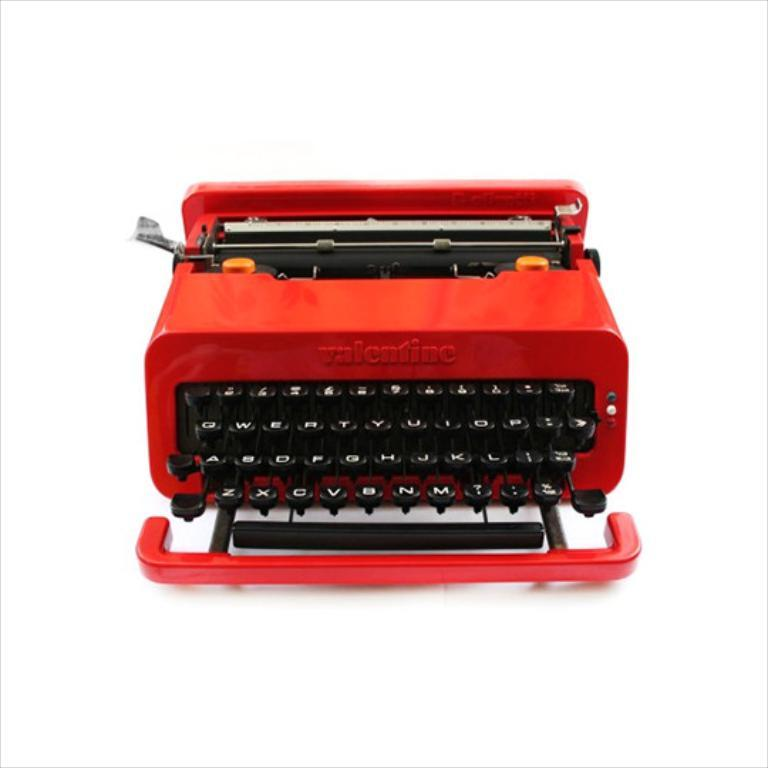<image>
Render a clear and concise summary of the photo. a typewriter that is red and says Velentine 